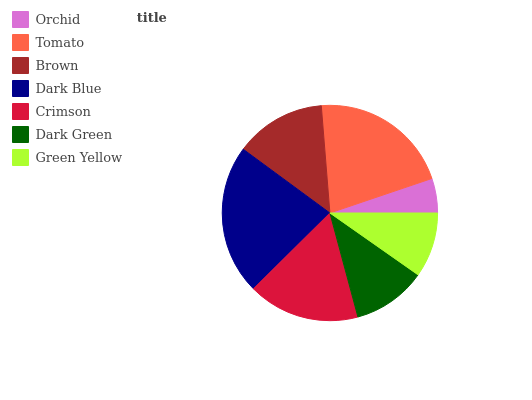Is Orchid the minimum?
Answer yes or no. Yes. Is Dark Blue the maximum?
Answer yes or no. Yes. Is Tomato the minimum?
Answer yes or no. No. Is Tomato the maximum?
Answer yes or no. No. Is Tomato greater than Orchid?
Answer yes or no. Yes. Is Orchid less than Tomato?
Answer yes or no. Yes. Is Orchid greater than Tomato?
Answer yes or no. No. Is Tomato less than Orchid?
Answer yes or no. No. Is Brown the high median?
Answer yes or no. Yes. Is Brown the low median?
Answer yes or no. Yes. Is Green Yellow the high median?
Answer yes or no. No. Is Dark Blue the low median?
Answer yes or no. No. 